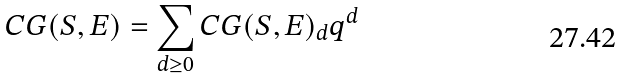<formula> <loc_0><loc_0><loc_500><loc_500>C G ( S , E ) = \sum _ { d \geq 0 } C G ( S , E ) _ { d } q ^ { d }</formula> 